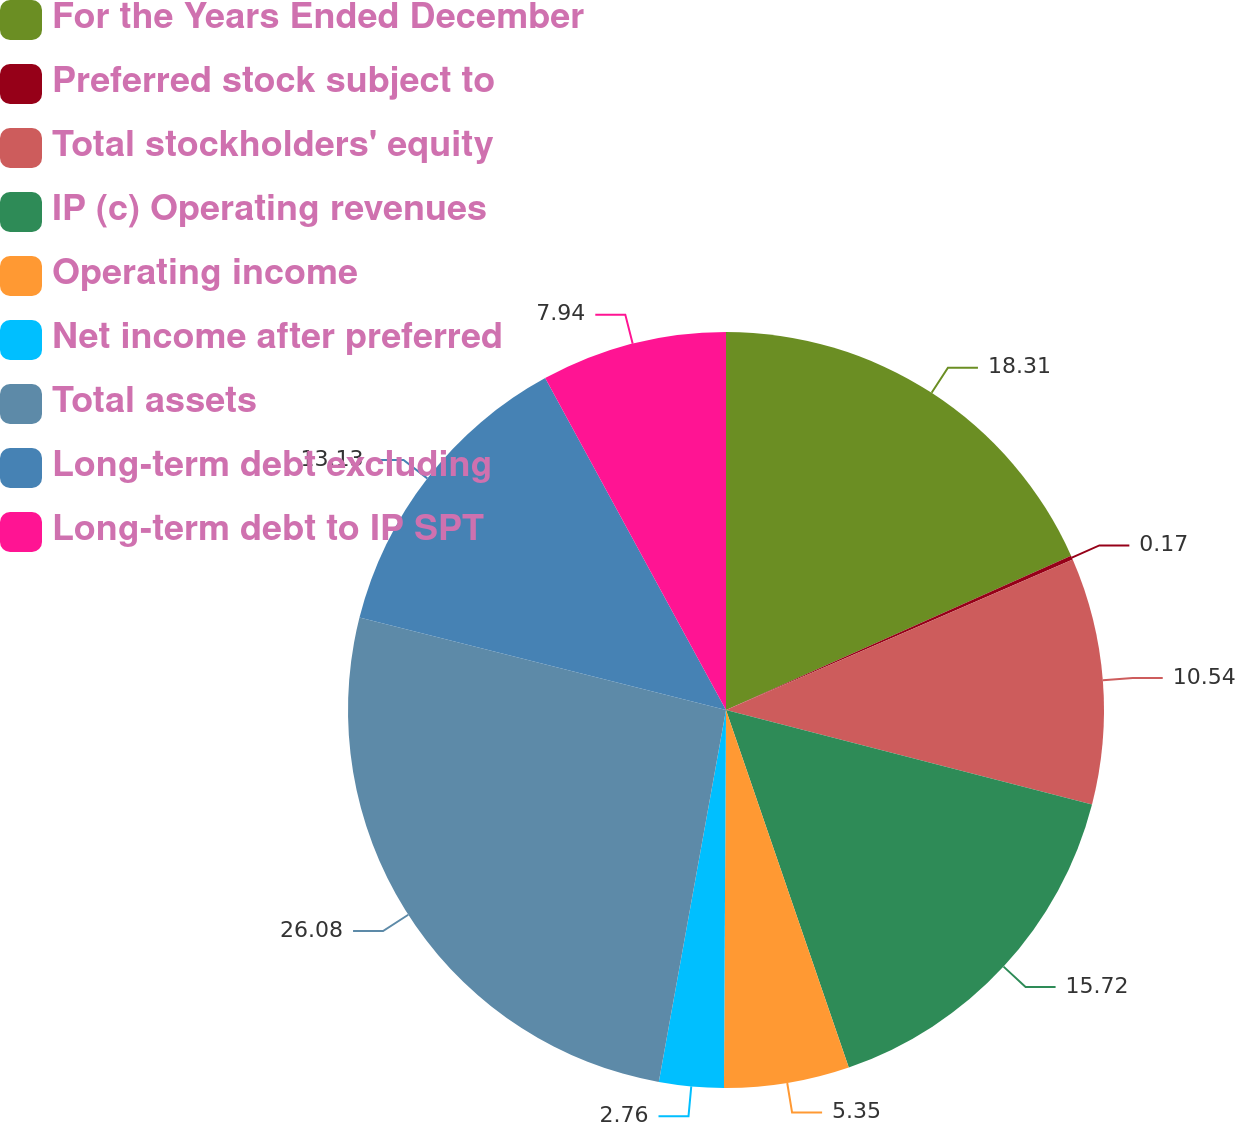<chart> <loc_0><loc_0><loc_500><loc_500><pie_chart><fcel>For the Years Ended December<fcel>Preferred stock subject to<fcel>Total stockholders' equity<fcel>IP (c) Operating revenues<fcel>Operating income<fcel>Net income after preferred<fcel>Total assets<fcel>Long-term debt excluding<fcel>Long-term debt to IP SPT<nl><fcel>18.31%<fcel>0.17%<fcel>10.54%<fcel>15.72%<fcel>5.35%<fcel>2.76%<fcel>26.09%<fcel>13.13%<fcel>7.94%<nl></chart> 